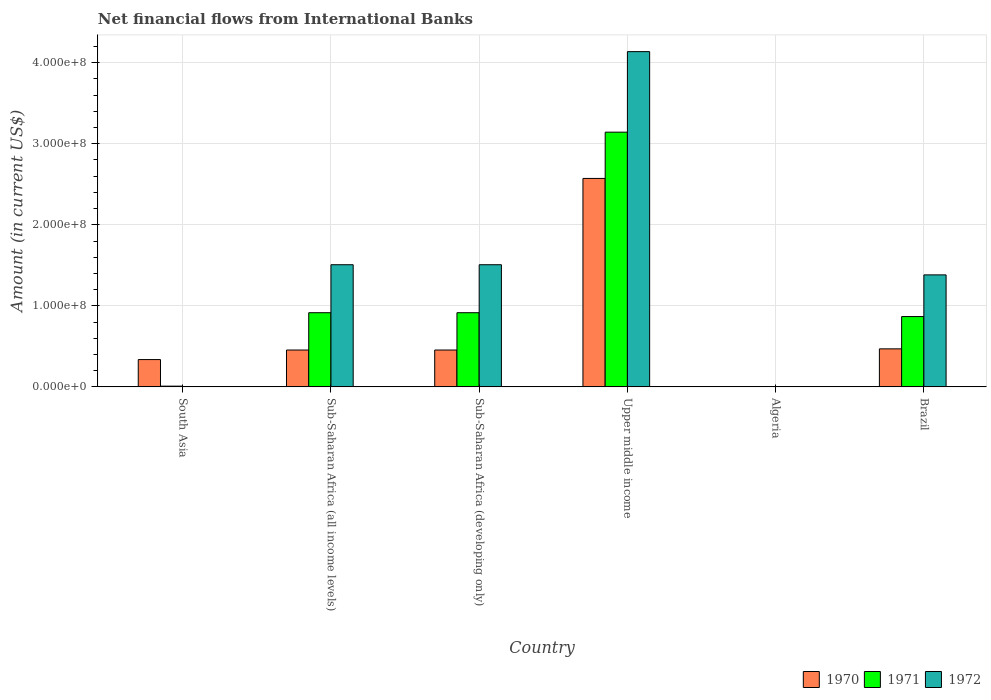How many bars are there on the 3rd tick from the left?
Your answer should be very brief. 3. What is the label of the 6th group of bars from the left?
Make the answer very short. Brazil. What is the net financial aid flows in 1970 in Brazil?
Your answer should be compact. 4.69e+07. Across all countries, what is the maximum net financial aid flows in 1971?
Your answer should be compact. 3.14e+08. Across all countries, what is the minimum net financial aid flows in 1972?
Provide a succinct answer. 0. In which country was the net financial aid flows in 1971 maximum?
Make the answer very short. Upper middle income. What is the total net financial aid flows in 1971 in the graph?
Provide a short and direct response. 5.85e+08. What is the difference between the net financial aid flows in 1971 in South Asia and that in Upper middle income?
Give a very brief answer. -3.13e+08. What is the difference between the net financial aid flows in 1970 in Algeria and the net financial aid flows in 1972 in Upper middle income?
Ensure brevity in your answer.  -4.14e+08. What is the average net financial aid flows in 1970 per country?
Give a very brief answer. 7.15e+07. What is the difference between the net financial aid flows of/in 1970 and net financial aid flows of/in 1971 in Sub-Saharan Africa (developing only)?
Your answer should be compact. -4.61e+07. In how many countries, is the net financial aid flows in 1972 greater than 120000000 US$?
Your answer should be very brief. 4. What is the ratio of the net financial aid flows in 1970 in Brazil to that in Upper middle income?
Keep it short and to the point. 0.18. Is the difference between the net financial aid flows in 1970 in South Asia and Sub-Saharan Africa (developing only) greater than the difference between the net financial aid flows in 1971 in South Asia and Sub-Saharan Africa (developing only)?
Make the answer very short. Yes. What is the difference between the highest and the second highest net financial aid flows in 1970?
Offer a terse response. 2.12e+08. What is the difference between the highest and the lowest net financial aid flows in 1972?
Provide a short and direct response. 4.14e+08. In how many countries, is the net financial aid flows in 1971 greater than the average net financial aid flows in 1971 taken over all countries?
Give a very brief answer. 1. Is it the case that in every country, the sum of the net financial aid flows in 1970 and net financial aid flows in 1971 is greater than the net financial aid flows in 1972?
Provide a succinct answer. No. How many countries are there in the graph?
Give a very brief answer. 6. What is the difference between two consecutive major ticks on the Y-axis?
Offer a very short reply. 1.00e+08. Are the values on the major ticks of Y-axis written in scientific E-notation?
Ensure brevity in your answer.  Yes. Does the graph contain any zero values?
Provide a succinct answer. Yes. Where does the legend appear in the graph?
Provide a short and direct response. Bottom right. How many legend labels are there?
Offer a terse response. 3. How are the legend labels stacked?
Keep it short and to the point. Horizontal. What is the title of the graph?
Your answer should be very brief. Net financial flows from International Banks. What is the Amount (in current US$) in 1970 in South Asia?
Your answer should be compact. 3.37e+07. What is the Amount (in current US$) of 1971 in South Asia?
Your answer should be very brief. 8.91e+05. What is the Amount (in current US$) in 1972 in South Asia?
Ensure brevity in your answer.  0. What is the Amount (in current US$) of 1970 in Sub-Saharan Africa (all income levels)?
Provide a succinct answer. 4.55e+07. What is the Amount (in current US$) in 1971 in Sub-Saharan Africa (all income levels)?
Your answer should be compact. 9.15e+07. What is the Amount (in current US$) of 1972 in Sub-Saharan Africa (all income levels)?
Provide a succinct answer. 1.51e+08. What is the Amount (in current US$) in 1970 in Sub-Saharan Africa (developing only)?
Your answer should be very brief. 4.55e+07. What is the Amount (in current US$) of 1971 in Sub-Saharan Africa (developing only)?
Keep it short and to the point. 9.15e+07. What is the Amount (in current US$) in 1972 in Sub-Saharan Africa (developing only)?
Your answer should be very brief. 1.51e+08. What is the Amount (in current US$) in 1970 in Upper middle income?
Your answer should be compact. 2.57e+08. What is the Amount (in current US$) of 1971 in Upper middle income?
Your answer should be very brief. 3.14e+08. What is the Amount (in current US$) of 1972 in Upper middle income?
Provide a succinct answer. 4.14e+08. What is the Amount (in current US$) of 1972 in Algeria?
Your answer should be very brief. 0. What is the Amount (in current US$) of 1970 in Brazil?
Make the answer very short. 4.69e+07. What is the Amount (in current US$) of 1971 in Brazil?
Offer a terse response. 8.68e+07. What is the Amount (in current US$) in 1972 in Brazil?
Your answer should be compact. 1.38e+08. Across all countries, what is the maximum Amount (in current US$) of 1970?
Offer a terse response. 2.57e+08. Across all countries, what is the maximum Amount (in current US$) of 1971?
Ensure brevity in your answer.  3.14e+08. Across all countries, what is the maximum Amount (in current US$) of 1972?
Ensure brevity in your answer.  4.14e+08. Across all countries, what is the minimum Amount (in current US$) of 1972?
Your response must be concise. 0. What is the total Amount (in current US$) in 1970 in the graph?
Your answer should be compact. 4.29e+08. What is the total Amount (in current US$) of 1971 in the graph?
Make the answer very short. 5.85e+08. What is the total Amount (in current US$) in 1972 in the graph?
Ensure brevity in your answer.  8.53e+08. What is the difference between the Amount (in current US$) of 1970 in South Asia and that in Sub-Saharan Africa (all income levels)?
Ensure brevity in your answer.  -1.18e+07. What is the difference between the Amount (in current US$) of 1971 in South Asia and that in Sub-Saharan Africa (all income levels)?
Your answer should be very brief. -9.06e+07. What is the difference between the Amount (in current US$) in 1970 in South Asia and that in Sub-Saharan Africa (developing only)?
Your answer should be very brief. -1.18e+07. What is the difference between the Amount (in current US$) of 1971 in South Asia and that in Sub-Saharan Africa (developing only)?
Provide a succinct answer. -9.06e+07. What is the difference between the Amount (in current US$) in 1970 in South Asia and that in Upper middle income?
Give a very brief answer. -2.24e+08. What is the difference between the Amount (in current US$) in 1971 in South Asia and that in Upper middle income?
Ensure brevity in your answer.  -3.13e+08. What is the difference between the Amount (in current US$) of 1970 in South Asia and that in Brazil?
Give a very brief answer. -1.32e+07. What is the difference between the Amount (in current US$) of 1971 in South Asia and that in Brazil?
Provide a succinct answer. -8.59e+07. What is the difference between the Amount (in current US$) of 1970 in Sub-Saharan Africa (all income levels) and that in Sub-Saharan Africa (developing only)?
Provide a short and direct response. 0. What is the difference between the Amount (in current US$) of 1971 in Sub-Saharan Africa (all income levels) and that in Sub-Saharan Africa (developing only)?
Ensure brevity in your answer.  0. What is the difference between the Amount (in current US$) of 1972 in Sub-Saharan Africa (all income levels) and that in Sub-Saharan Africa (developing only)?
Give a very brief answer. 0. What is the difference between the Amount (in current US$) of 1970 in Sub-Saharan Africa (all income levels) and that in Upper middle income?
Offer a very short reply. -2.12e+08. What is the difference between the Amount (in current US$) in 1971 in Sub-Saharan Africa (all income levels) and that in Upper middle income?
Give a very brief answer. -2.23e+08. What is the difference between the Amount (in current US$) of 1972 in Sub-Saharan Africa (all income levels) and that in Upper middle income?
Offer a very short reply. -2.63e+08. What is the difference between the Amount (in current US$) of 1970 in Sub-Saharan Africa (all income levels) and that in Brazil?
Offer a very short reply. -1.45e+06. What is the difference between the Amount (in current US$) in 1971 in Sub-Saharan Africa (all income levels) and that in Brazil?
Provide a short and direct response. 4.75e+06. What is the difference between the Amount (in current US$) in 1972 in Sub-Saharan Africa (all income levels) and that in Brazil?
Provide a succinct answer. 1.25e+07. What is the difference between the Amount (in current US$) in 1970 in Sub-Saharan Africa (developing only) and that in Upper middle income?
Make the answer very short. -2.12e+08. What is the difference between the Amount (in current US$) in 1971 in Sub-Saharan Africa (developing only) and that in Upper middle income?
Ensure brevity in your answer.  -2.23e+08. What is the difference between the Amount (in current US$) of 1972 in Sub-Saharan Africa (developing only) and that in Upper middle income?
Offer a terse response. -2.63e+08. What is the difference between the Amount (in current US$) in 1970 in Sub-Saharan Africa (developing only) and that in Brazil?
Offer a very short reply. -1.45e+06. What is the difference between the Amount (in current US$) of 1971 in Sub-Saharan Africa (developing only) and that in Brazil?
Offer a very short reply. 4.75e+06. What is the difference between the Amount (in current US$) of 1972 in Sub-Saharan Africa (developing only) and that in Brazil?
Provide a short and direct response. 1.25e+07. What is the difference between the Amount (in current US$) of 1970 in Upper middle income and that in Brazil?
Your answer should be very brief. 2.10e+08. What is the difference between the Amount (in current US$) of 1971 in Upper middle income and that in Brazil?
Ensure brevity in your answer.  2.28e+08. What is the difference between the Amount (in current US$) of 1972 in Upper middle income and that in Brazil?
Offer a terse response. 2.75e+08. What is the difference between the Amount (in current US$) in 1970 in South Asia and the Amount (in current US$) in 1971 in Sub-Saharan Africa (all income levels)?
Provide a succinct answer. -5.78e+07. What is the difference between the Amount (in current US$) in 1970 in South Asia and the Amount (in current US$) in 1972 in Sub-Saharan Africa (all income levels)?
Provide a short and direct response. -1.17e+08. What is the difference between the Amount (in current US$) of 1971 in South Asia and the Amount (in current US$) of 1972 in Sub-Saharan Africa (all income levels)?
Make the answer very short. -1.50e+08. What is the difference between the Amount (in current US$) of 1970 in South Asia and the Amount (in current US$) of 1971 in Sub-Saharan Africa (developing only)?
Provide a succinct answer. -5.78e+07. What is the difference between the Amount (in current US$) of 1970 in South Asia and the Amount (in current US$) of 1972 in Sub-Saharan Africa (developing only)?
Your response must be concise. -1.17e+08. What is the difference between the Amount (in current US$) in 1971 in South Asia and the Amount (in current US$) in 1972 in Sub-Saharan Africa (developing only)?
Keep it short and to the point. -1.50e+08. What is the difference between the Amount (in current US$) in 1970 in South Asia and the Amount (in current US$) in 1971 in Upper middle income?
Ensure brevity in your answer.  -2.81e+08. What is the difference between the Amount (in current US$) in 1970 in South Asia and the Amount (in current US$) in 1972 in Upper middle income?
Give a very brief answer. -3.80e+08. What is the difference between the Amount (in current US$) in 1971 in South Asia and the Amount (in current US$) in 1972 in Upper middle income?
Your answer should be very brief. -4.13e+08. What is the difference between the Amount (in current US$) in 1970 in South Asia and the Amount (in current US$) in 1971 in Brazil?
Make the answer very short. -5.31e+07. What is the difference between the Amount (in current US$) in 1970 in South Asia and the Amount (in current US$) in 1972 in Brazil?
Provide a short and direct response. -1.05e+08. What is the difference between the Amount (in current US$) of 1971 in South Asia and the Amount (in current US$) of 1972 in Brazil?
Your answer should be very brief. -1.37e+08. What is the difference between the Amount (in current US$) in 1970 in Sub-Saharan Africa (all income levels) and the Amount (in current US$) in 1971 in Sub-Saharan Africa (developing only)?
Your answer should be compact. -4.61e+07. What is the difference between the Amount (in current US$) in 1970 in Sub-Saharan Africa (all income levels) and the Amount (in current US$) in 1972 in Sub-Saharan Africa (developing only)?
Provide a succinct answer. -1.05e+08. What is the difference between the Amount (in current US$) of 1971 in Sub-Saharan Africa (all income levels) and the Amount (in current US$) of 1972 in Sub-Saharan Africa (developing only)?
Ensure brevity in your answer.  -5.92e+07. What is the difference between the Amount (in current US$) of 1970 in Sub-Saharan Africa (all income levels) and the Amount (in current US$) of 1971 in Upper middle income?
Make the answer very short. -2.69e+08. What is the difference between the Amount (in current US$) of 1970 in Sub-Saharan Africa (all income levels) and the Amount (in current US$) of 1972 in Upper middle income?
Keep it short and to the point. -3.68e+08. What is the difference between the Amount (in current US$) in 1971 in Sub-Saharan Africa (all income levels) and the Amount (in current US$) in 1972 in Upper middle income?
Your response must be concise. -3.22e+08. What is the difference between the Amount (in current US$) of 1970 in Sub-Saharan Africa (all income levels) and the Amount (in current US$) of 1971 in Brazil?
Ensure brevity in your answer.  -4.13e+07. What is the difference between the Amount (in current US$) in 1970 in Sub-Saharan Africa (all income levels) and the Amount (in current US$) in 1972 in Brazil?
Your response must be concise. -9.27e+07. What is the difference between the Amount (in current US$) in 1971 in Sub-Saharan Africa (all income levels) and the Amount (in current US$) in 1972 in Brazil?
Your response must be concise. -4.67e+07. What is the difference between the Amount (in current US$) of 1970 in Sub-Saharan Africa (developing only) and the Amount (in current US$) of 1971 in Upper middle income?
Your answer should be very brief. -2.69e+08. What is the difference between the Amount (in current US$) of 1970 in Sub-Saharan Africa (developing only) and the Amount (in current US$) of 1972 in Upper middle income?
Your response must be concise. -3.68e+08. What is the difference between the Amount (in current US$) of 1971 in Sub-Saharan Africa (developing only) and the Amount (in current US$) of 1972 in Upper middle income?
Your answer should be very brief. -3.22e+08. What is the difference between the Amount (in current US$) of 1970 in Sub-Saharan Africa (developing only) and the Amount (in current US$) of 1971 in Brazil?
Give a very brief answer. -4.13e+07. What is the difference between the Amount (in current US$) of 1970 in Sub-Saharan Africa (developing only) and the Amount (in current US$) of 1972 in Brazil?
Provide a succinct answer. -9.27e+07. What is the difference between the Amount (in current US$) in 1971 in Sub-Saharan Africa (developing only) and the Amount (in current US$) in 1972 in Brazil?
Your answer should be very brief. -4.67e+07. What is the difference between the Amount (in current US$) in 1970 in Upper middle income and the Amount (in current US$) in 1971 in Brazil?
Provide a short and direct response. 1.70e+08. What is the difference between the Amount (in current US$) of 1970 in Upper middle income and the Amount (in current US$) of 1972 in Brazil?
Offer a very short reply. 1.19e+08. What is the difference between the Amount (in current US$) of 1971 in Upper middle income and the Amount (in current US$) of 1972 in Brazil?
Your answer should be very brief. 1.76e+08. What is the average Amount (in current US$) in 1970 per country?
Offer a terse response. 7.15e+07. What is the average Amount (in current US$) in 1971 per country?
Make the answer very short. 9.75e+07. What is the average Amount (in current US$) of 1972 per country?
Give a very brief answer. 1.42e+08. What is the difference between the Amount (in current US$) in 1970 and Amount (in current US$) in 1971 in South Asia?
Your answer should be very brief. 3.28e+07. What is the difference between the Amount (in current US$) of 1970 and Amount (in current US$) of 1971 in Sub-Saharan Africa (all income levels)?
Give a very brief answer. -4.61e+07. What is the difference between the Amount (in current US$) in 1970 and Amount (in current US$) in 1972 in Sub-Saharan Africa (all income levels)?
Provide a short and direct response. -1.05e+08. What is the difference between the Amount (in current US$) in 1971 and Amount (in current US$) in 1972 in Sub-Saharan Africa (all income levels)?
Ensure brevity in your answer.  -5.92e+07. What is the difference between the Amount (in current US$) of 1970 and Amount (in current US$) of 1971 in Sub-Saharan Africa (developing only)?
Make the answer very short. -4.61e+07. What is the difference between the Amount (in current US$) of 1970 and Amount (in current US$) of 1972 in Sub-Saharan Africa (developing only)?
Offer a terse response. -1.05e+08. What is the difference between the Amount (in current US$) in 1971 and Amount (in current US$) in 1972 in Sub-Saharan Africa (developing only)?
Offer a very short reply. -5.92e+07. What is the difference between the Amount (in current US$) in 1970 and Amount (in current US$) in 1971 in Upper middle income?
Offer a terse response. -5.71e+07. What is the difference between the Amount (in current US$) in 1970 and Amount (in current US$) in 1972 in Upper middle income?
Your answer should be compact. -1.56e+08. What is the difference between the Amount (in current US$) of 1971 and Amount (in current US$) of 1972 in Upper middle income?
Keep it short and to the point. -9.94e+07. What is the difference between the Amount (in current US$) of 1970 and Amount (in current US$) of 1971 in Brazil?
Provide a succinct answer. -3.99e+07. What is the difference between the Amount (in current US$) in 1970 and Amount (in current US$) in 1972 in Brazil?
Your response must be concise. -9.13e+07. What is the difference between the Amount (in current US$) of 1971 and Amount (in current US$) of 1972 in Brazil?
Your answer should be compact. -5.14e+07. What is the ratio of the Amount (in current US$) in 1970 in South Asia to that in Sub-Saharan Africa (all income levels)?
Your response must be concise. 0.74. What is the ratio of the Amount (in current US$) of 1971 in South Asia to that in Sub-Saharan Africa (all income levels)?
Your answer should be compact. 0.01. What is the ratio of the Amount (in current US$) of 1970 in South Asia to that in Sub-Saharan Africa (developing only)?
Offer a terse response. 0.74. What is the ratio of the Amount (in current US$) of 1971 in South Asia to that in Sub-Saharan Africa (developing only)?
Your answer should be very brief. 0.01. What is the ratio of the Amount (in current US$) in 1970 in South Asia to that in Upper middle income?
Give a very brief answer. 0.13. What is the ratio of the Amount (in current US$) of 1971 in South Asia to that in Upper middle income?
Your answer should be compact. 0. What is the ratio of the Amount (in current US$) in 1970 in South Asia to that in Brazil?
Offer a terse response. 0.72. What is the ratio of the Amount (in current US$) in 1971 in South Asia to that in Brazil?
Your answer should be very brief. 0.01. What is the ratio of the Amount (in current US$) in 1970 in Sub-Saharan Africa (all income levels) to that in Sub-Saharan Africa (developing only)?
Offer a very short reply. 1. What is the ratio of the Amount (in current US$) in 1970 in Sub-Saharan Africa (all income levels) to that in Upper middle income?
Keep it short and to the point. 0.18. What is the ratio of the Amount (in current US$) of 1971 in Sub-Saharan Africa (all income levels) to that in Upper middle income?
Offer a terse response. 0.29. What is the ratio of the Amount (in current US$) in 1972 in Sub-Saharan Africa (all income levels) to that in Upper middle income?
Your answer should be compact. 0.36. What is the ratio of the Amount (in current US$) of 1970 in Sub-Saharan Africa (all income levels) to that in Brazil?
Give a very brief answer. 0.97. What is the ratio of the Amount (in current US$) of 1971 in Sub-Saharan Africa (all income levels) to that in Brazil?
Your answer should be compact. 1.05. What is the ratio of the Amount (in current US$) of 1972 in Sub-Saharan Africa (all income levels) to that in Brazil?
Offer a very short reply. 1.09. What is the ratio of the Amount (in current US$) of 1970 in Sub-Saharan Africa (developing only) to that in Upper middle income?
Keep it short and to the point. 0.18. What is the ratio of the Amount (in current US$) in 1971 in Sub-Saharan Africa (developing only) to that in Upper middle income?
Provide a short and direct response. 0.29. What is the ratio of the Amount (in current US$) of 1972 in Sub-Saharan Africa (developing only) to that in Upper middle income?
Offer a terse response. 0.36. What is the ratio of the Amount (in current US$) in 1970 in Sub-Saharan Africa (developing only) to that in Brazil?
Ensure brevity in your answer.  0.97. What is the ratio of the Amount (in current US$) in 1971 in Sub-Saharan Africa (developing only) to that in Brazil?
Your response must be concise. 1.05. What is the ratio of the Amount (in current US$) in 1972 in Sub-Saharan Africa (developing only) to that in Brazil?
Give a very brief answer. 1.09. What is the ratio of the Amount (in current US$) in 1970 in Upper middle income to that in Brazil?
Your answer should be very brief. 5.48. What is the ratio of the Amount (in current US$) of 1971 in Upper middle income to that in Brazil?
Your answer should be very brief. 3.62. What is the ratio of the Amount (in current US$) in 1972 in Upper middle income to that in Brazil?
Your response must be concise. 2.99. What is the difference between the highest and the second highest Amount (in current US$) in 1970?
Make the answer very short. 2.10e+08. What is the difference between the highest and the second highest Amount (in current US$) in 1971?
Offer a very short reply. 2.23e+08. What is the difference between the highest and the second highest Amount (in current US$) in 1972?
Offer a terse response. 2.63e+08. What is the difference between the highest and the lowest Amount (in current US$) in 1970?
Offer a very short reply. 2.57e+08. What is the difference between the highest and the lowest Amount (in current US$) in 1971?
Ensure brevity in your answer.  3.14e+08. What is the difference between the highest and the lowest Amount (in current US$) of 1972?
Offer a very short reply. 4.14e+08. 